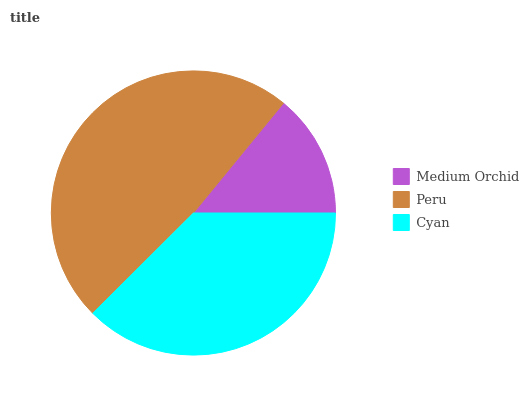Is Medium Orchid the minimum?
Answer yes or no. Yes. Is Peru the maximum?
Answer yes or no. Yes. Is Cyan the minimum?
Answer yes or no. No. Is Cyan the maximum?
Answer yes or no. No. Is Peru greater than Cyan?
Answer yes or no. Yes. Is Cyan less than Peru?
Answer yes or no. Yes. Is Cyan greater than Peru?
Answer yes or no. No. Is Peru less than Cyan?
Answer yes or no. No. Is Cyan the high median?
Answer yes or no. Yes. Is Cyan the low median?
Answer yes or no. Yes. Is Peru the high median?
Answer yes or no. No. Is Peru the low median?
Answer yes or no. No. 